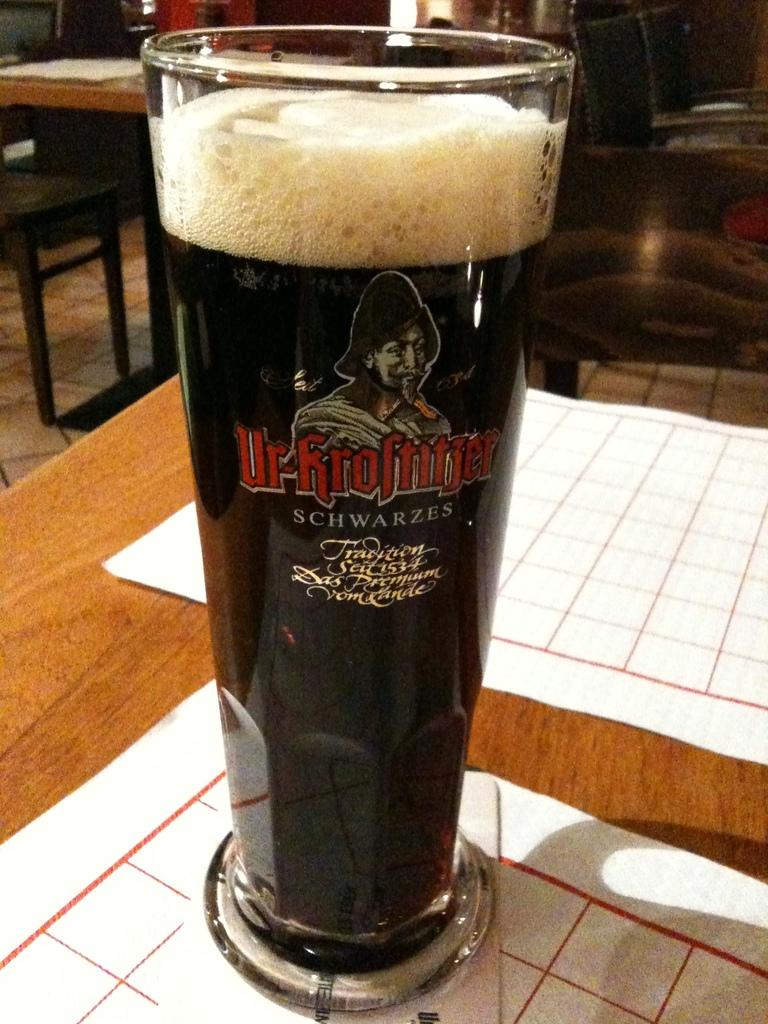What object is placed on the table in the image? There is a glass on a table in the image. What part of the room can be seen in the image? The floor is visible in the image. What type of apparel is the passenger wearing in the image? There is no passenger present in the image, so it is not possible to determine what type of apparel they might be wearing. 